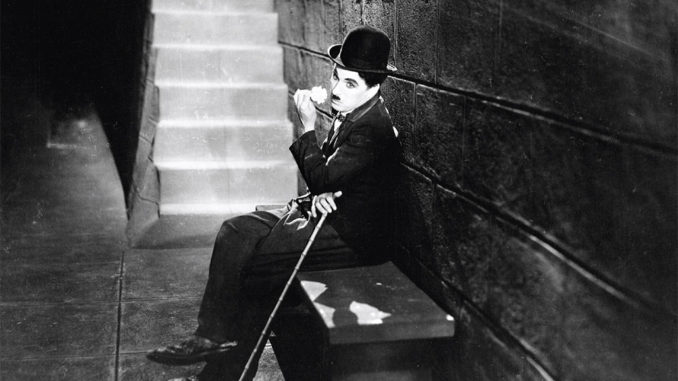Can you discuss the significance of Chaplin's attire in enhancing his character's identity? Certainly! Chaplin's attire, consisting of a tight coat, baggy pants, and oversized shoes, coupled with a small bowler hat, crafts a unique visual paradox that aligns with his Tramp character. This costume choice not only makes him immediately recognizable but also symbolizes the incongruities present in early 20th-century society - the struggle to maintain dignity in downtrodden circumstances. Each element of his attire is carefully chosen to reflect the socio-economic themes woven throughout his films, making his clothing a critical part of his storytelling. 